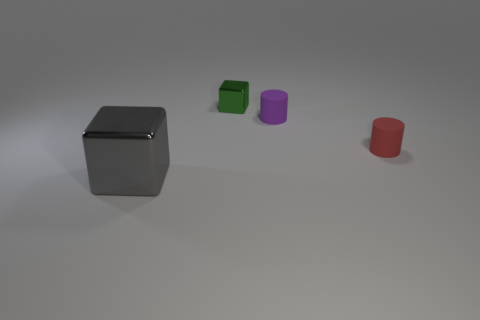What are the materials and colors of the objects in the image? The objects appear to be 3D renderings where the large block in the foreground is a reflective metal, the cube is green, the cylinder looks purple, and the truncated cone is red. 